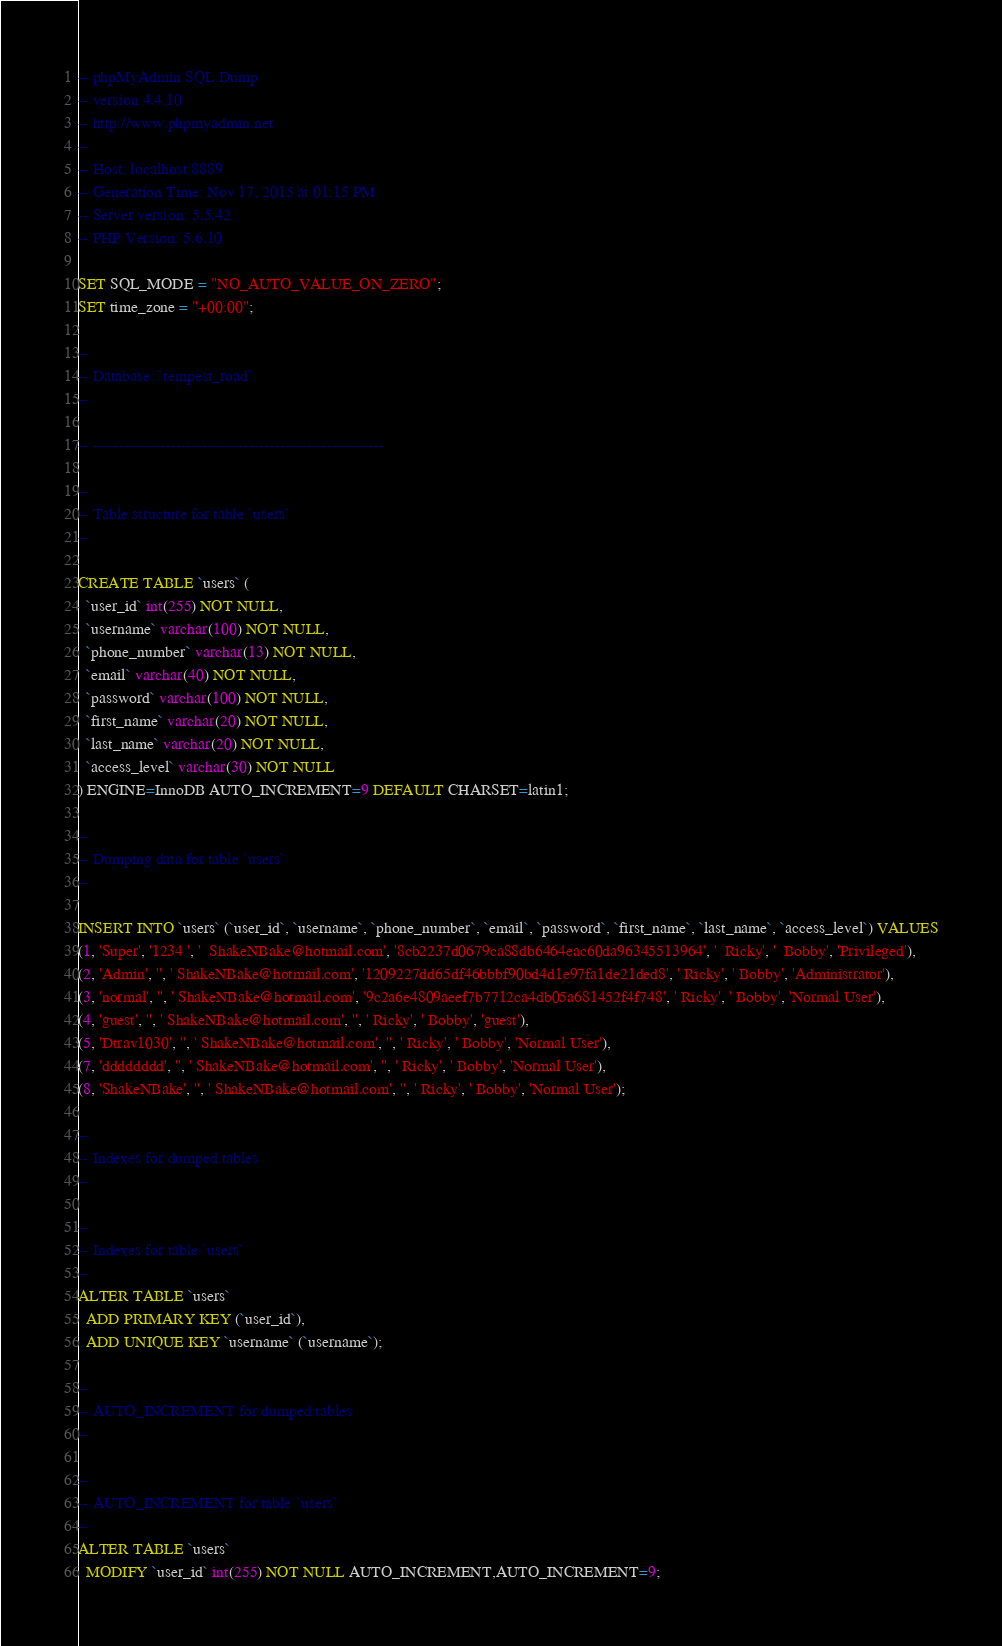<code> <loc_0><loc_0><loc_500><loc_500><_SQL_>-- phpMyAdmin SQL Dump
-- version 4.4.10
-- http://www.phpmyadmin.net
--
-- Host: localhost:8889
-- Generation Time: Nov 17, 2015 at 01:15 PM
-- Server version: 5.5.42
-- PHP Version: 5.6.10

SET SQL_MODE = "NO_AUTO_VALUE_ON_ZERO";
SET time_zone = "+00:00";

--
-- Database: `tempest_road`
--

-- --------------------------------------------------------

--
-- Table structure for table `users`
--

CREATE TABLE `users` (
  `user_id` int(255) NOT NULL,
  `username` varchar(100) NOT NULL,
  `phone_number` varchar(13) NOT NULL,
  `email` varchar(40) NOT NULL,
  `password` varchar(100) NOT NULL,
  `first_name` varchar(20) NOT NULL,
  `last_name` varchar(20) NOT NULL,
  `access_level` varchar(30) NOT NULL
) ENGINE=InnoDB AUTO_INCREMENT=9 DEFAULT CHARSET=latin1;

--
-- Dumping data for table `users`
--

INSERT INTO `users` (`user_id`, `username`, `phone_number`, `email`, `password`, `first_name`, `last_name`, `access_level`) VALUES
(1, 'Super', '1234 ', '  ShakeNBake@hotmail.com', '8cb2237d0679ca88db6464eac60da96345513964', '  Ricky', '  Bobby', 'Privileged'),
(2, 'Admin', '', ' ShakeNBake@hotmail.com', '1209227dd65df46bbbf90bd4d1e97fa1de21ded8', ' Ricky', ' Bobby', 'Administrator'),
(3, 'normal', '', ' ShakeNBake@hotmail.com', '9c2a6e4809aeef7b7712ca4db05a681452f4f748', ' Ricky', ' Bobby', 'Normal User'),
(4, 'guest', '', ' ShakeNBake@hotmail.com', '', ' Ricky', ' Bobby', 'guest'),
(5, 'Dtrav1030', '', ' ShakeNBake@hotmail.com', '', ' Ricky', ' Bobby', 'Normal User'),
(7, 'dddddddd', '', ' ShakeNBake@hotmail.com', '', ' Ricky', ' Bobby', 'Normal User'),
(8, 'ShakeNBake', '', ' ShakeNBake@hotmail.com', '', ' Ricky', ' Bobby', 'Normal User');

--
-- Indexes for dumped tables
--

--
-- Indexes for table `users`
--
ALTER TABLE `users`
  ADD PRIMARY KEY (`user_id`),
  ADD UNIQUE KEY `username` (`username`);

--
-- AUTO_INCREMENT for dumped tables
--

--
-- AUTO_INCREMENT for table `users`
--
ALTER TABLE `users`
  MODIFY `user_id` int(255) NOT NULL AUTO_INCREMENT,AUTO_INCREMENT=9;</code> 